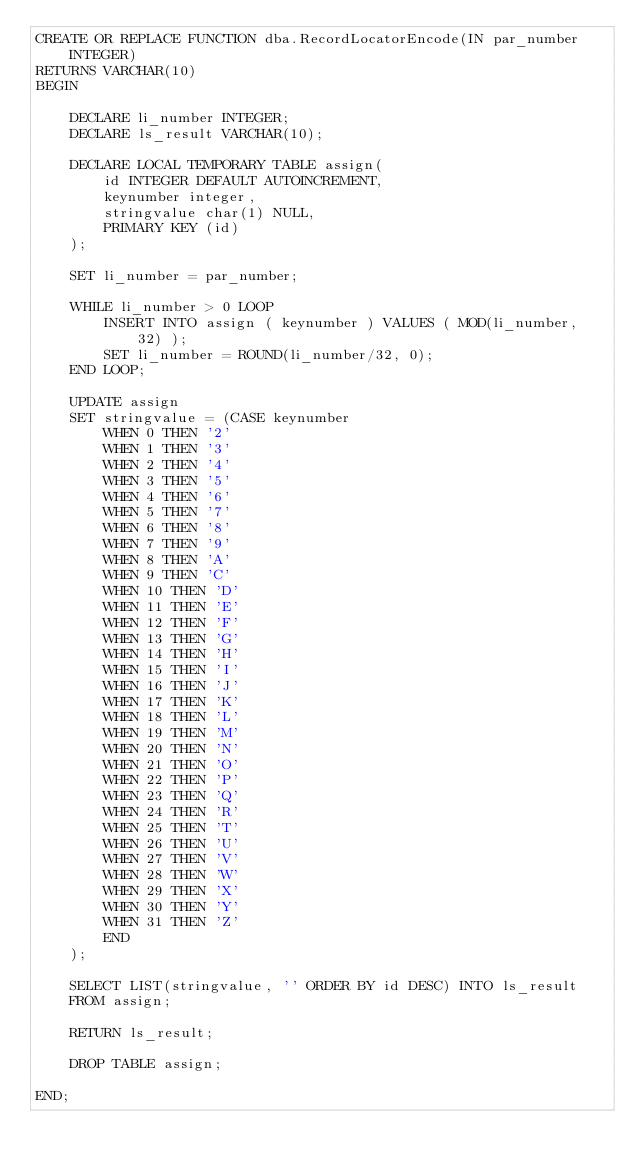Convert code to text. <code><loc_0><loc_0><loc_500><loc_500><_SQL_>CREATE OR REPLACE FUNCTION dba.RecordLocatorEncode(IN par_number INTEGER)
RETURNS VARCHAR(10)
BEGIN

    DECLARE li_number INTEGER;
    DECLARE ls_result VARCHAR(10);

    DECLARE LOCAL TEMPORARY TABLE assign(
        id INTEGER DEFAULT AUTOINCREMENT,
        keynumber integer,
        stringvalue char(1) NULL,
        PRIMARY KEY (id)
    );

    SET li_number = par_number;

    WHILE li_number > 0 LOOP
        INSERT INTO assign ( keynumber ) VALUES ( MOD(li_number, 32) );
        SET li_number = ROUND(li_number/32, 0);
    END LOOP;

    UPDATE assign
    SET stringvalue = (CASE keynumber
        WHEN 0 THEN '2'
        WHEN 1 THEN '3'
        WHEN 2 THEN '4'
        WHEN 3 THEN '5'
        WHEN 4 THEN '6'
        WHEN 5 THEN '7'
        WHEN 6 THEN '8'
        WHEN 7 THEN '9'
        WHEN 8 THEN 'A'
        WHEN 9 THEN 'C'
        WHEN 10 THEN 'D'
        WHEN 11 THEN 'E'
        WHEN 12 THEN 'F'
        WHEN 13 THEN 'G'
        WHEN 14 THEN 'H'
        WHEN 15 THEN 'I'
        WHEN 16 THEN 'J'
        WHEN 17 THEN 'K'
        WHEN 18 THEN 'L'
        WHEN 19 THEN 'M'
        WHEN 20 THEN 'N'
        WHEN 21 THEN 'O'
        WHEN 22 THEN 'P'
        WHEN 23 THEN 'Q'
        WHEN 24 THEN 'R'
        WHEN 25 THEN 'T'
        WHEN 26 THEN 'U'
        WHEN 27 THEN 'V'
        WHEN 28 THEN 'W'
        WHEN 29 THEN 'X'
        WHEN 30 THEN 'Y'
        WHEN 31 THEN 'Z'
        END
    );

    SELECT LIST(stringvalue, '' ORDER BY id DESC) INTO ls_result
    FROM assign;

    RETURN ls_result;

    DROP TABLE assign;

END;</code> 